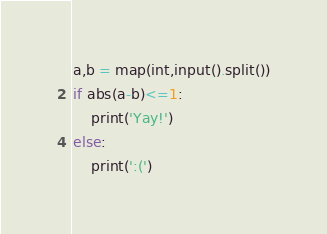Convert code to text. <code><loc_0><loc_0><loc_500><loc_500><_Python_>a,b = map(int,input().split())
if abs(a-b)<=1:
    print('Yay!')
else:
    print(':(')
</code> 